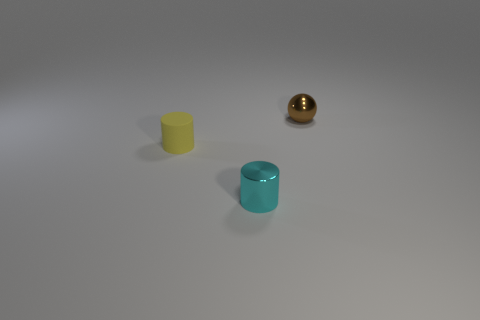What number of tiny things are to the right of the brown shiny sphere? To the right of the brown shiny sphere, there are no tiny objects present. 